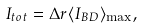<formula> <loc_0><loc_0><loc_500><loc_500>I _ { t o t } = \Delta r \langle I _ { B D } \rangle _ { \max } ,</formula> 